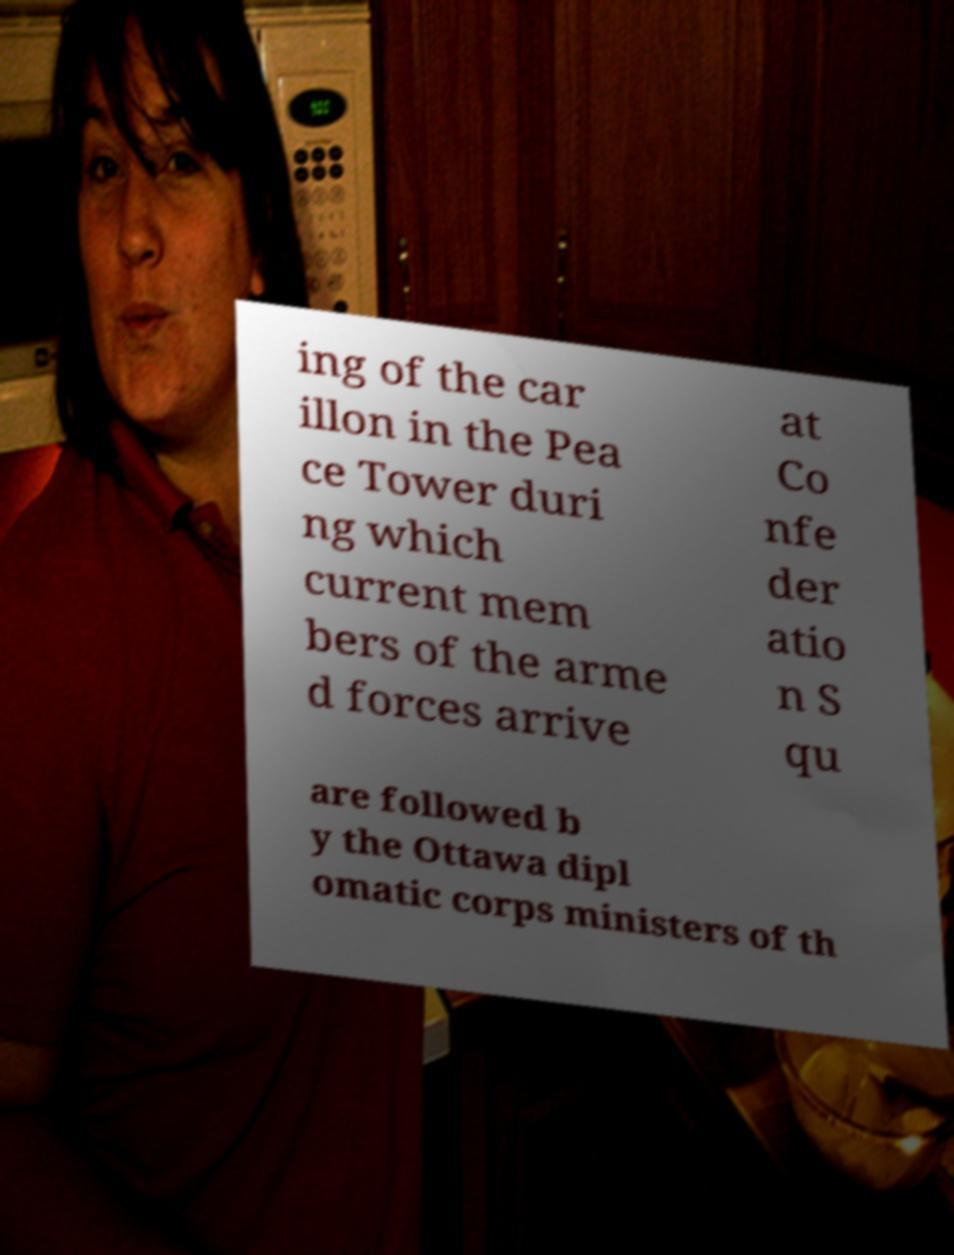I need the written content from this picture converted into text. Can you do that? ing of the car illon in the Pea ce Tower duri ng which current mem bers of the arme d forces arrive at Co nfe der atio n S qu are followed b y the Ottawa dipl omatic corps ministers of th 